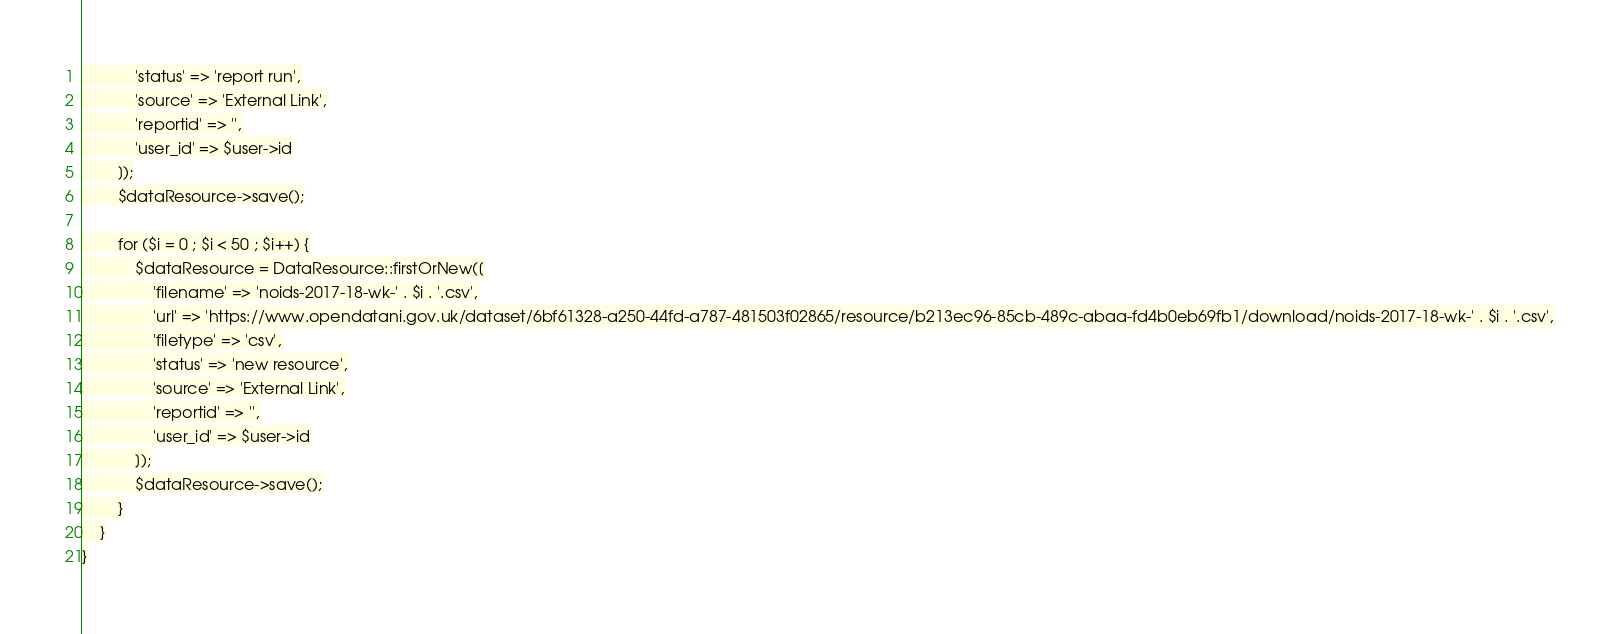Convert code to text. <code><loc_0><loc_0><loc_500><loc_500><_PHP_>            'status' => 'report run',
            'source' => 'External Link',
            'reportid' => '',
            'user_id' => $user->id
        ]);
        $dataResource->save();

        for ($i = 0 ; $i < 50 ; $i++) {
            $dataResource = DataResource::firstOrNew([
                'filename' => 'noids-2017-18-wk-' . $i . '.csv',
                'url' => 'https://www.opendatani.gov.uk/dataset/6bf61328-a250-44fd-a787-481503f02865/resource/b213ec96-85cb-489c-abaa-fd4b0eb69fb1/download/noids-2017-18-wk-' . $i . '.csv',
                'filetype' => 'csv',
                'status' => 'new resource',
                'source' => 'External Link',
                'reportid' => '',
                'user_id' => $user->id
            ]);
            $dataResource->save();
        }
    }
}
</code> 